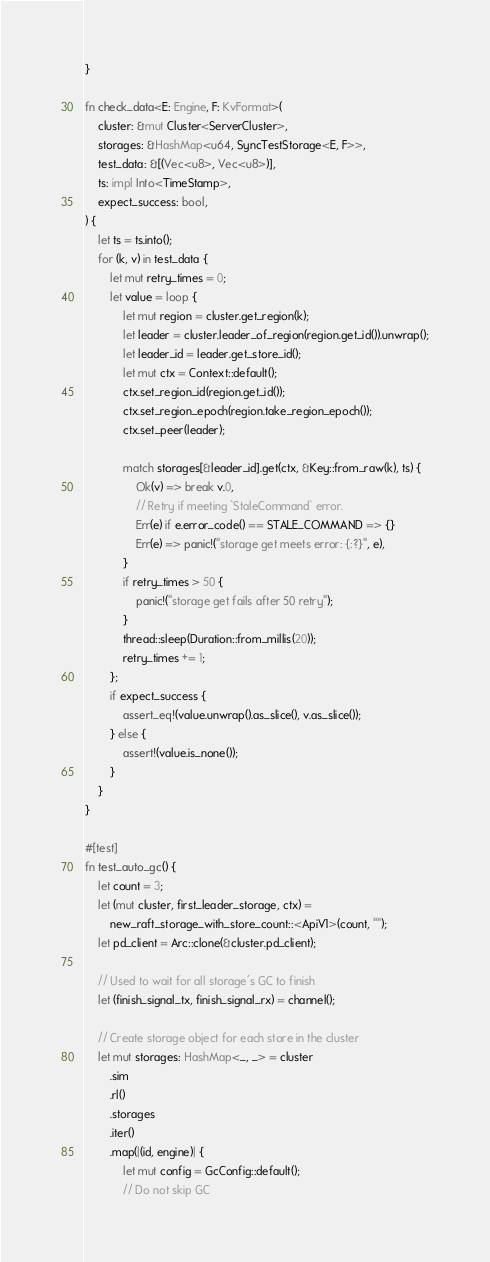<code> <loc_0><loc_0><loc_500><loc_500><_Rust_>}

fn check_data<E: Engine, F: KvFormat>(
    cluster: &mut Cluster<ServerCluster>,
    storages: &HashMap<u64, SyncTestStorage<E, F>>,
    test_data: &[(Vec<u8>, Vec<u8>)],
    ts: impl Into<TimeStamp>,
    expect_success: bool,
) {
    let ts = ts.into();
    for (k, v) in test_data {
        let mut retry_times = 0;
        let value = loop {
            let mut region = cluster.get_region(k);
            let leader = cluster.leader_of_region(region.get_id()).unwrap();
            let leader_id = leader.get_store_id();
            let mut ctx = Context::default();
            ctx.set_region_id(region.get_id());
            ctx.set_region_epoch(region.take_region_epoch());
            ctx.set_peer(leader);

            match storages[&leader_id].get(ctx, &Key::from_raw(k), ts) {
                Ok(v) => break v.0,
                // Retry if meeting `StaleCommand` error.
                Err(e) if e.error_code() == STALE_COMMAND => {}
                Err(e) => panic!("storage get meets error: {:?}", e),
            }
            if retry_times > 50 {
                panic!("storage get fails after 50 retry");
            }
            thread::sleep(Duration::from_millis(20));
            retry_times += 1;
        };
        if expect_success {
            assert_eq!(value.unwrap().as_slice(), v.as_slice());
        } else {
            assert!(value.is_none());
        }
    }
}

#[test]
fn test_auto_gc() {
    let count = 3;
    let (mut cluster, first_leader_storage, ctx) =
        new_raft_storage_with_store_count::<ApiV1>(count, "");
    let pd_client = Arc::clone(&cluster.pd_client);

    // Used to wait for all storage's GC to finish
    let (finish_signal_tx, finish_signal_rx) = channel();

    // Create storage object for each store in the cluster
    let mut storages: HashMap<_, _> = cluster
        .sim
        .rl()
        .storages
        .iter()
        .map(|(id, engine)| {
            let mut config = GcConfig::default();
            // Do not skip GC</code> 